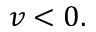<formula> <loc_0><loc_0><loc_500><loc_500>v < 0 .</formula> 